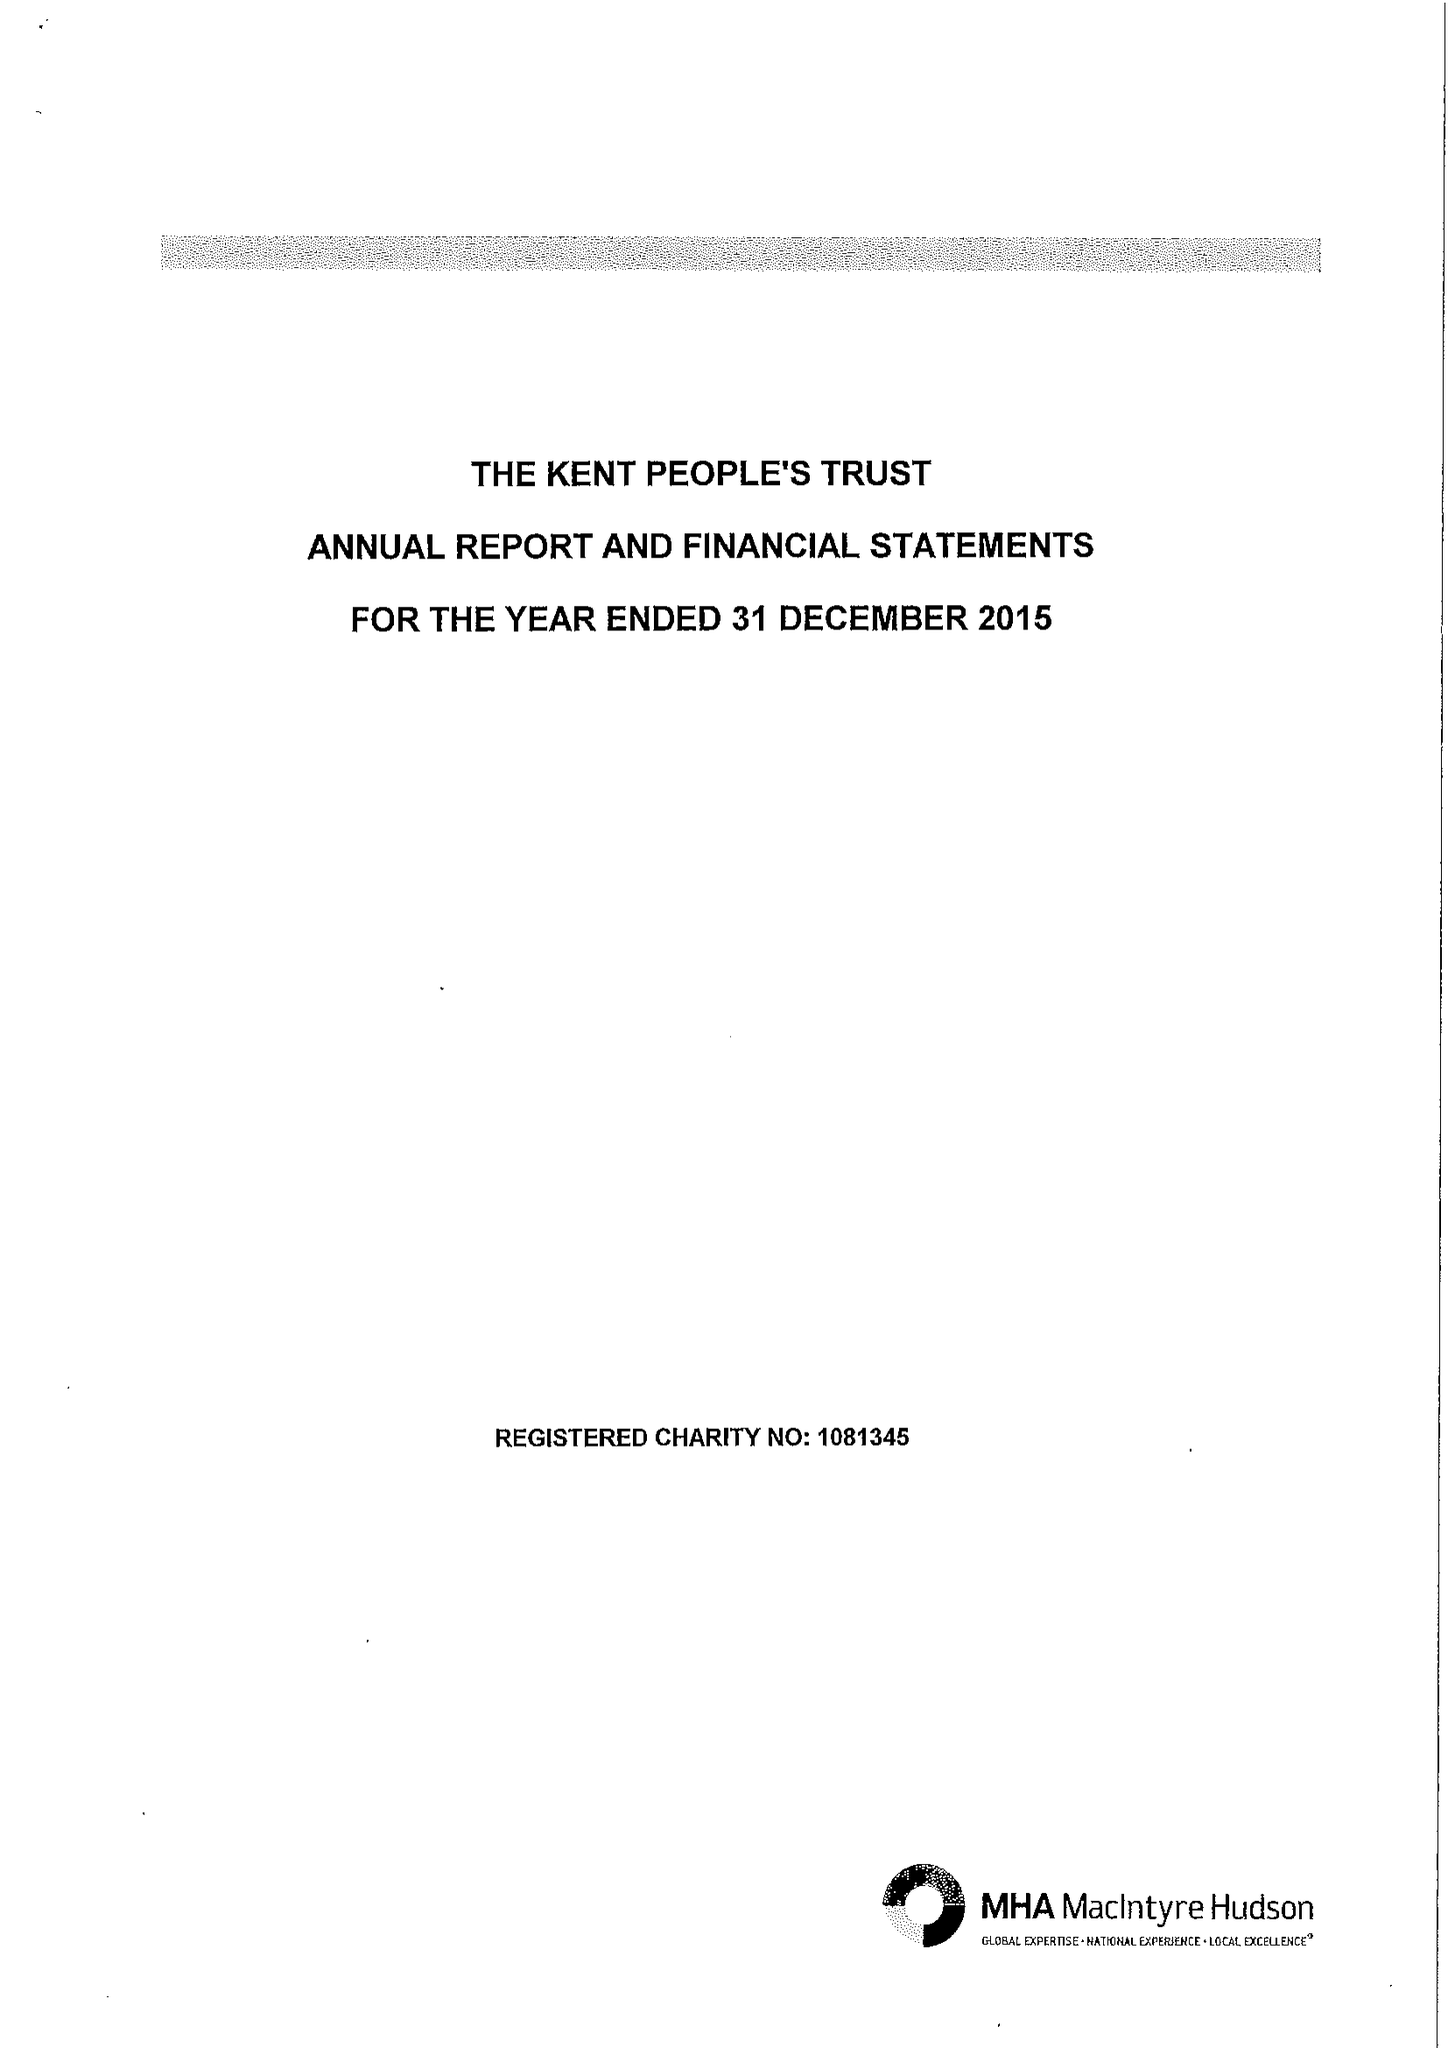What is the value for the report_date?
Answer the question using a single word or phrase. 2015-12-31 